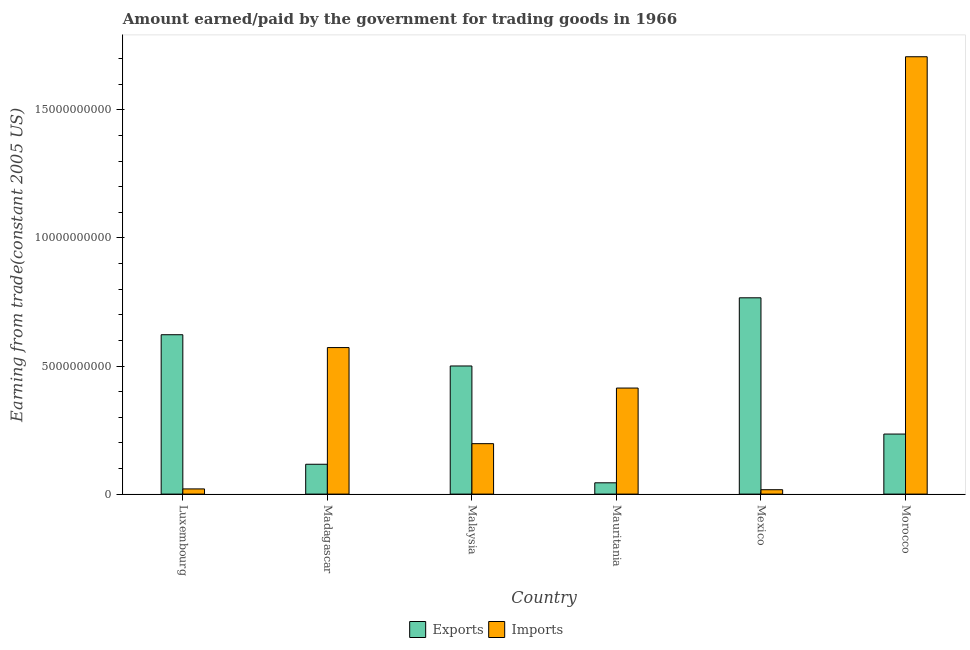How many different coloured bars are there?
Offer a very short reply. 2. How many groups of bars are there?
Your response must be concise. 6. Are the number of bars per tick equal to the number of legend labels?
Offer a terse response. Yes. Are the number of bars on each tick of the X-axis equal?
Give a very brief answer. Yes. What is the amount earned from exports in Mexico?
Ensure brevity in your answer.  7.66e+09. Across all countries, what is the maximum amount earned from exports?
Make the answer very short. 7.66e+09. Across all countries, what is the minimum amount paid for imports?
Provide a succinct answer. 1.71e+08. What is the total amount earned from exports in the graph?
Offer a very short reply. 2.28e+1. What is the difference between the amount earned from exports in Madagascar and that in Mauritania?
Offer a very short reply. 7.24e+08. What is the difference between the amount earned from exports in Mauritania and the amount paid for imports in Morocco?
Provide a succinct answer. -1.66e+1. What is the average amount earned from exports per country?
Give a very brief answer. 3.81e+09. What is the difference between the amount earned from exports and amount paid for imports in Madagascar?
Keep it short and to the point. -4.56e+09. What is the ratio of the amount earned from exports in Madagascar to that in Mauritania?
Make the answer very short. 2.64. Is the difference between the amount paid for imports in Luxembourg and Mauritania greater than the difference between the amount earned from exports in Luxembourg and Mauritania?
Your answer should be compact. No. What is the difference between the highest and the second highest amount earned from exports?
Keep it short and to the point. 1.44e+09. What is the difference between the highest and the lowest amount earned from exports?
Your response must be concise. 7.22e+09. Is the sum of the amount earned from exports in Madagascar and Morocco greater than the maximum amount paid for imports across all countries?
Ensure brevity in your answer.  No. What does the 2nd bar from the left in Malaysia represents?
Keep it short and to the point. Imports. What does the 2nd bar from the right in Madagascar represents?
Make the answer very short. Exports. How many bars are there?
Your answer should be compact. 12. Are all the bars in the graph horizontal?
Your answer should be very brief. No. What is the difference between two consecutive major ticks on the Y-axis?
Your answer should be very brief. 5.00e+09. Does the graph contain any zero values?
Your answer should be compact. No. Where does the legend appear in the graph?
Ensure brevity in your answer.  Bottom center. How many legend labels are there?
Your answer should be compact. 2. What is the title of the graph?
Your answer should be very brief. Amount earned/paid by the government for trading goods in 1966. Does "current US$" appear as one of the legend labels in the graph?
Keep it short and to the point. No. What is the label or title of the Y-axis?
Make the answer very short. Earning from trade(constant 2005 US). What is the Earning from trade(constant 2005 US) of Exports in Luxembourg?
Keep it short and to the point. 6.22e+09. What is the Earning from trade(constant 2005 US) of Imports in Luxembourg?
Offer a terse response. 2.03e+08. What is the Earning from trade(constant 2005 US) of Exports in Madagascar?
Your response must be concise. 1.16e+09. What is the Earning from trade(constant 2005 US) of Imports in Madagascar?
Provide a short and direct response. 5.72e+09. What is the Earning from trade(constant 2005 US) of Exports in Malaysia?
Your response must be concise. 5.00e+09. What is the Earning from trade(constant 2005 US) of Imports in Malaysia?
Provide a succinct answer. 1.97e+09. What is the Earning from trade(constant 2005 US) of Exports in Mauritania?
Give a very brief answer. 4.41e+08. What is the Earning from trade(constant 2005 US) in Imports in Mauritania?
Keep it short and to the point. 4.14e+09. What is the Earning from trade(constant 2005 US) of Exports in Mexico?
Ensure brevity in your answer.  7.66e+09. What is the Earning from trade(constant 2005 US) of Imports in Mexico?
Offer a very short reply. 1.71e+08. What is the Earning from trade(constant 2005 US) in Exports in Morocco?
Make the answer very short. 2.34e+09. What is the Earning from trade(constant 2005 US) in Imports in Morocco?
Provide a succinct answer. 1.71e+1. Across all countries, what is the maximum Earning from trade(constant 2005 US) of Exports?
Your answer should be very brief. 7.66e+09. Across all countries, what is the maximum Earning from trade(constant 2005 US) in Imports?
Provide a short and direct response. 1.71e+1. Across all countries, what is the minimum Earning from trade(constant 2005 US) of Exports?
Provide a succinct answer. 4.41e+08. Across all countries, what is the minimum Earning from trade(constant 2005 US) of Imports?
Provide a succinct answer. 1.71e+08. What is the total Earning from trade(constant 2005 US) of Exports in the graph?
Make the answer very short. 2.28e+1. What is the total Earning from trade(constant 2005 US) in Imports in the graph?
Give a very brief answer. 2.93e+1. What is the difference between the Earning from trade(constant 2005 US) of Exports in Luxembourg and that in Madagascar?
Offer a terse response. 5.06e+09. What is the difference between the Earning from trade(constant 2005 US) in Imports in Luxembourg and that in Madagascar?
Your answer should be compact. -5.52e+09. What is the difference between the Earning from trade(constant 2005 US) in Exports in Luxembourg and that in Malaysia?
Your answer should be very brief. 1.22e+09. What is the difference between the Earning from trade(constant 2005 US) of Imports in Luxembourg and that in Malaysia?
Give a very brief answer. -1.77e+09. What is the difference between the Earning from trade(constant 2005 US) in Exports in Luxembourg and that in Mauritania?
Provide a short and direct response. 5.78e+09. What is the difference between the Earning from trade(constant 2005 US) of Imports in Luxembourg and that in Mauritania?
Offer a terse response. -3.94e+09. What is the difference between the Earning from trade(constant 2005 US) of Exports in Luxembourg and that in Mexico?
Give a very brief answer. -1.44e+09. What is the difference between the Earning from trade(constant 2005 US) in Imports in Luxembourg and that in Mexico?
Provide a short and direct response. 3.14e+07. What is the difference between the Earning from trade(constant 2005 US) of Exports in Luxembourg and that in Morocco?
Your answer should be very brief. 3.88e+09. What is the difference between the Earning from trade(constant 2005 US) of Imports in Luxembourg and that in Morocco?
Make the answer very short. -1.69e+1. What is the difference between the Earning from trade(constant 2005 US) in Exports in Madagascar and that in Malaysia?
Provide a succinct answer. -3.84e+09. What is the difference between the Earning from trade(constant 2005 US) in Imports in Madagascar and that in Malaysia?
Keep it short and to the point. 3.75e+09. What is the difference between the Earning from trade(constant 2005 US) of Exports in Madagascar and that in Mauritania?
Offer a terse response. 7.24e+08. What is the difference between the Earning from trade(constant 2005 US) in Imports in Madagascar and that in Mauritania?
Provide a succinct answer. 1.58e+09. What is the difference between the Earning from trade(constant 2005 US) in Exports in Madagascar and that in Mexico?
Make the answer very short. -6.50e+09. What is the difference between the Earning from trade(constant 2005 US) of Imports in Madagascar and that in Mexico?
Provide a short and direct response. 5.55e+09. What is the difference between the Earning from trade(constant 2005 US) of Exports in Madagascar and that in Morocco?
Your response must be concise. -1.18e+09. What is the difference between the Earning from trade(constant 2005 US) in Imports in Madagascar and that in Morocco?
Provide a short and direct response. -1.14e+1. What is the difference between the Earning from trade(constant 2005 US) in Exports in Malaysia and that in Mauritania?
Ensure brevity in your answer.  4.56e+09. What is the difference between the Earning from trade(constant 2005 US) of Imports in Malaysia and that in Mauritania?
Your response must be concise. -2.17e+09. What is the difference between the Earning from trade(constant 2005 US) in Exports in Malaysia and that in Mexico?
Your answer should be compact. -2.66e+09. What is the difference between the Earning from trade(constant 2005 US) of Imports in Malaysia and that in Mexico?
Offer a very short reply. 1.80e+09. What is the difference between the Earning from trade(constant 2005 US) in Exports in Malaysia and that in Morocco?
Make the answer very short. 2.66e+09. What is the difference between the Earning from trade(constant 2005 US) of Imports in Malaysia and that in Morocco?
Ensure brevity in your answer.  -1.51e+1. What is the difference between the Earning from trade(constant 2005 US) in Exports in Mauritania and that in Mexico?
Give a very brief answer. -7.22e+09. What is the difference between the Earning from trade(constant 2005 US) of Imports in Mauritania and that in Mexico?
Your answer should be very brief. 3.97e+09. What is the difference between the Earning from trade(constant 2005 US) of Exports in Mauritania and that in Morocco?
Make the answer very short. -1.90e+09. What is the difference between the Earning from trade(constant 2005 US) of Imports in Mauritania and that in Morocco?
Offer a terse response. -1.29e+1. What is the difference between the Earning from trade(constant 2005 US) in Exports in Mexico and that in Morocco?
Your answer should be very brief. 5.32e+09. What is the difference between the Earning from trade(constant 2005 US) of Imports in Mexico and that in Morocco?
Provide a succinct answer. -1.69e+1. What is the difference between the Earning from trade(constant 2005 US) of Exports in Luxembourg and the Earning from trade(constant 2005 US) of Imports in Madagascar?
Keep it short and to the point. 5.01e+08. What is the difference between the Earning from trade(constant 2005 US) of Exports in Luxembourg and the Earning from trade(constant 2005 US) of Imports in Malaysia?
Your answer should be compact. 4.25e+09. What is the difference between the Earning from trade(constant 2005 US) in Exports in Luxembourg and the Earning from trade(constant 2005 US) in Imports in Mauritania?
Offer a very short reply. 2.08e+09. What is the difference between the Earning from trade(constant 2005 US) in Exports in Luxembourg and the Earning from trade(constant 2005 US) in Imports in Mexico?
Offer a very short reply. 6.05e+09. What is the difference between the Earning from trade(constant 2005 US) in Exports in Luxembourg and the Earning from trade(constant 2005 US) in Imports in Morocco?
Make the answer very short. -1.09e+1. What is the difference between the Earning from trade(constant 2005 US) in Exports in Madagascar and the Earning from trade(constant 2005 US) in Imports in Malaysia?
Offer a terse response. -8.04e+08. What is the difference between the Earning from trade(constant 2005 US) in Exports in Madagascar and the Earning from trade(constant 2005 US) in Imports in Mauritania?
Make the answer very short. -2.98e+09. What is the difference between the Earning from trade(constant 2005 US) in Exports in Madagascar and the Earning from trade(constant 2005 US) in Imports in Mexico?
Keep it short and to the point. 9.94e+08. What is the difference between the Earning from trade(constant 2005 US) in Exports in Madagascar and the Earning from trade(constant 2005 US) in Imports in Morocco?
Ensure brevity in your answer.  -1.59e+1. What is the difference between the Earning from trade(constant 2005 US) in Exports in Malaysia and the Earning from trade(constant 2005 US) in Imports in Mauritania?
Ensure brevity in your answer.  8.62e+08. What is the difference between the Earning from trade(constant 2005 US) in Exports in Malaysia and the Earning from trade(constant 2005 US) in Imports in Mexico?
Your response must be concise. 4.83e+09. What is the difference between the Earning from trade(constant 2005 US) of Exports in Malaysia and the Earning from trade(constant 2005 US) of Imports in Morocco?
Offer a very short reply. -1.21e+1. What is the difference between the Earning from trade(constant 2005 US) in Exports in Mauritania and the Earning from trade(constant 2005 US) in Imports in Mexico?
Keep it short and to the point. 2.70e+08. What is the difference between the Earning from trade(constant 2005 US) of Exports in Mauritania and the Earning from trade(constant 2005 US) of Imports in Morocco?
Give a very brief answer. -1.66e+1. What is the difference between the Earning from trade(constant 2005 US) in Exports in Mexico and the Earning from trade(constant 2005 US) in Imports in Morocco?
Provide a short and direct response. -9.41e+09. What is the average Earning from trade(constant 2005 US) of Exports per country?
Keep it short and to the point. 3.81e+09. What is the average Earning from trade(constant 2005 US) of Imports per country?
Your answer should be compact. 4.88e+09. What is the difference between the Earning from trade(constant 2005 US) of Exports and Earning from trade(constant 2005 US) of Imports in Luxembourg?
Your response must be concise. 6.02e+09. What is the difference between the Earning from trade(constant 2005 US) of Exports and Earning from trade(constant 2005 US) of Imports in Madagascar?
Ensure brevity in your answer.  -4.56e+09. What is the difference between the Earning from trade(constant 2005 US) in Exports and Earning from trade(constant 2005 US) in Imports in Malaysia?
Keep it short and to the point. 3.03e+09. What is the difference between the Earning from trade(constant 2005 US) in Exports and Earning from trade(constant 2005 US) in Imports in Mauritania?
Your answer should be compact. -3.70e+09. What is the difference between the Earning from trade(constant 2005 US) in Exports and Earning from trade(constant 2005 US) in Imports in Mexico?
Your answer should be compact. 7.49e+09. What is the difference between the Earning from trade(constant 2005 US) of Exports and Earning from trade(constant 2005 US) of Imports in Morocco?
Your response must be concise. -1.47e+1. What is the ratio of the Earning from trade(constant 2005 US) in Exports in Luxembourg to that in Madagascar?
Keep it short and to the point. 5.34. What is the ratio of the Earning from trade(constant 2005 US) in Imports in Luxembourg to that in Madagascar?
Provide a succinct answer. 0.04. What is the ratio of the Earning from trade(constant 2005 US) of Exports in Luxembourg to that in Malaysia?
Give a very brief answer. 1.24. What is the ratio of the Earning from trade(constant 2005 US) of Imports in Luxembourg to that in Malaysia?
Keep it short and to the point. 0.1. What is the ratio of the Earning from trade(constant 2005 US) in Exports in Luxembourg to that in Mauritania?
Offer a very short reply. 14.11. What is the ratio of the Earning from trade(constant 2005 US) of Imports in Luxembourg to that in Mauritania?
Your response must be concise. 0.05. What is the ratio of the Earning from trade(constant 2005 US) of Exports in Luxembourg to that in Mexico?
Ensure brevity in your answer.  0.81. What is the ratio of the Earning from trade(constant 2005 US) of Imports in Luxembourg to that in Mexico?
Offer a very short reply. 1.18. What is the ratio of the Earning from trade(constant 2005 US) of Exports in Luxembourg to that in Morocco?
Offer a terse response. 2.65. What is the ratio of the Earning from trade(constant 2005 US) of Imports in Luxembourg to that in Morocco?
Provide a short and direct response. 0.01. What is the ratio of the Earning from trade(constant 2005 US) in Exports in Madagascar to that in Malaysia?
Keep it short and to the point. 0.23. What is the ratio of the Earning from trade(constant 2005 US) of Imports in Madagascar to that in Malaysia?
Your response must be concise. 2.91. What is the ratio of the Earning from trade(constant 2005 US) of Exports in Madagascar to that in Mauritania?
Offer a terse response. 2.64. What is the ratio of the Earning from trade(constant 2005 US) of Imports in Madagascar to that in Mauritania?
Offer a terse response. 1.38. What is the ratio of the Earning from trade(constant 2005 US) of Exports in Madagascar to that in Mexico?
Your response must be concise. 0.15. What is the ratio of the Earning from trade(constant 2005 US) in Imports in Madagascar to that in Mexico?
Keep it short and to the point. 33.41. What is the ratio of the Earning from trade(constant 2005 US) in Exports in Madagascar to that in Morocco?
Provide a short and direct response. 0.5. What is the ratio of the Earning from trade(constant 2005 US) of Imports in Madagascar to that in Morocco?
Keep it short and to the point. 0.34. What is the ratio of the Earning from trade(constant 2005 US) of Exports in Malaysia to that in Mauritania?
Give a very brief answer. 11.34. What is the ratio of the Earning from trade(constant 2005 US) in Imports in Malaysia to that in Mauritania?
Offer a very short reply. 0.48. What is the ratio of the Earning from trade(constant 2005 US) of Exports in Malaysia to that in Mexico?
Your response must be concise. 0.65. What is the ratio of the Earning from trade(constant 2005 US) in Imports in Malaysia to that in Mexico?
Offer a terse response. 11.5. What is the ratio of the Earning from trade(constant 2005 US) of Exports in Malaysia to that in Morocco?
Your answer should be compact. 2.13. What is the ratio of the Earning from trade(constant 2005 US) of Imports in Malaysia to that in Morocco?
Offer a terse response. 0.12. What is the ratio of the Earning from trade(constant 2005 US) in Exports in Mauritania to that in Mexico?
Offer a terse response. 0.06. What is the ratio of the Earning from trade(constant 2005 US) in Imports in Mauritania to that in Mexico?
Give a very brief answer. 24.18. What is the ratio of the Earning from trade(constant 2005 US) of Exports in Mauritania to that in Morocco?
Provide a short and direct response. 0.19. What is the ratio of the Earning from trade(constant 2005 US) of Imports in Mauritania to that in Morocco?
Offer a very short reply. 0.24. What is the ratio of the Earning from trade(constant 2005 US) of Exports in Mexico to that in Morocco?
Your answer should be very brief. 3.27. What is the ratio of the Earning from trade(constant 2005 US) of Imports in Mexico to that in Morocco?
Your answer should be compact. 0.01. What is the difference between the highest and the second highest Earning from trade(constant 2005 US) of Exports?
Ensure brevity in your answer.  1.44e+09. What is the difference between the highest and the second highest Earning from trade(constant 2005 US) in Imports?
Provide a succinct answer. 1.14e+1. What is the difference between the highest and the lowest Earning from trade(constant 2005 US) in Exports?
Make the answer very short. 7.22e+09. What is the difference between the highest and the lowest Earning from trade(constant 2005 US) of Imports?
Your answer should be very brief. 1.69e+1. 